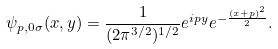<formula> <loc_0><loc_0><loc_500><loc_500>\psi _ { p , 0 \sigma } ( x , y ) = \frac { 1 } { ( 2 \pi ^ { 3 / 2 } ) ^ { 1 / 2 } } e ^ { i p y } e ^ { - \frac { ( x + p ) ^ { 2 } } { 2 } } .</formula> 